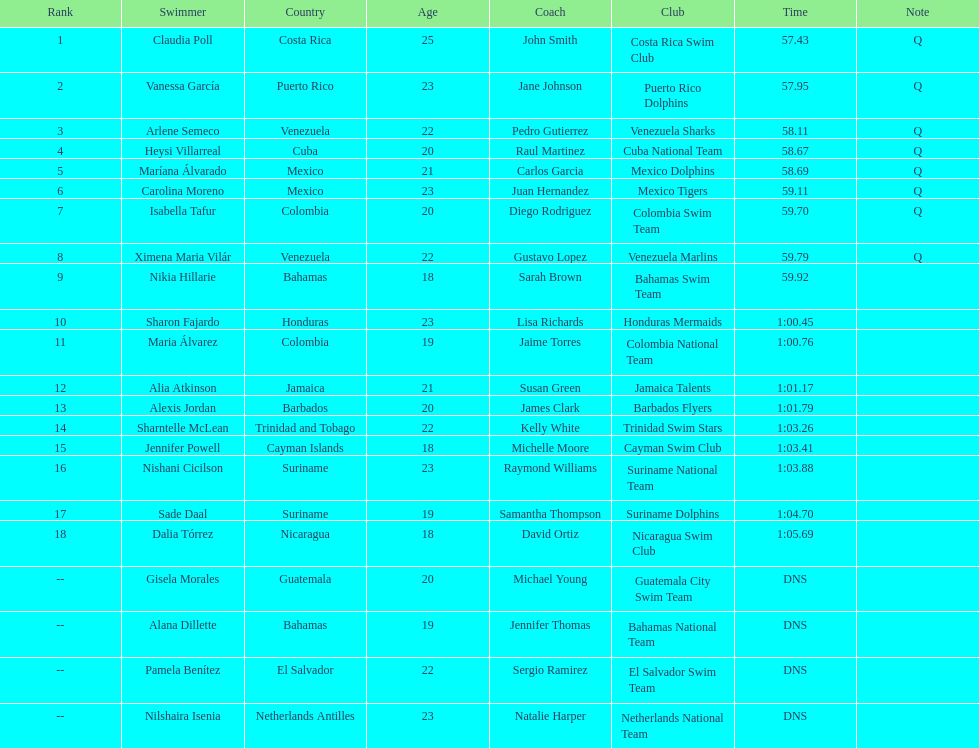Who was the only cuban to finish in the top eight? Heysi Villarreal. 